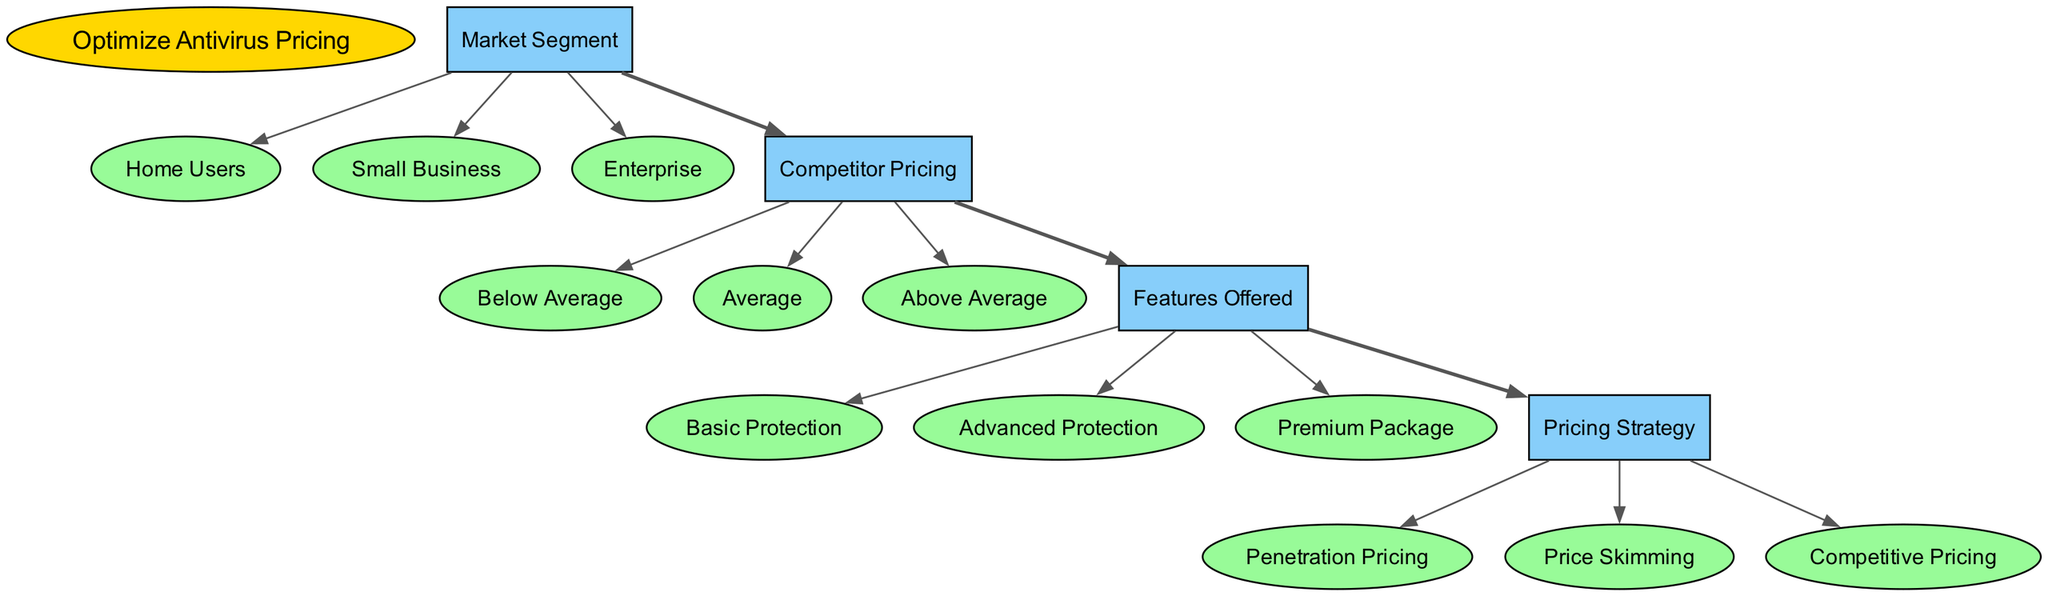What is the root node of the diagram? The root node is specified at the top of the diagram and is labeled "Optimize Antivirus Pricing."
Answer: Optimize Antivirus Pricing How many market segments are identified in the diagram? There are three distinct market segments listed under the "Market Segment" node: Home Users, Small Business, and Enterprise.
Answer: 3 What pricing strategy is associated with Advanced Protection? The "Features Offered" node leads to "Pricing Strategy," which includes all strategies regardless of the feature, but for Advanced Protection, the specific strategy could vary; it is not distinctly specified in the diagram. Since the diagram flows from "Features Offered" to "Pricing Strategy," the answer that applies generally is any of the pricing strategies could apply based on additional context.
Answer: Penetration Pricing, Price Skimming, Competitive Pricing Which node directly follows Competitor Pricing in the hierarchy? Competitor Pricing is followed by the "Features Offered" node, as shown by the defined edges indicating the flow from one to the other.
Answer: Features Offered What is the connection between Market Segment and Features Offered? The diagram specifies that there is an edge connecting "Market Segment" to "Competitor Pricing," and another edge from "Competitor Pricing" to "Features Offered," thus connecting the two indirectly through Competitor Pricing.
Answer: Indirectly through Competitor Pricing What is the number of edges in the diagram? The diagram shows three edges connecting the nodes, as detailed in the edges section. Each connection signifies a relationship between the nodes as outlined in the data.
Answer: 3 Which child node belongs to the "Features Offered"? Under "Features Offered," three child nodes are identified: Basic Protection, Advanced Protection, and Premium Package. Any of these would be a correct answer to the question.
Answer: Basic Protection What type of nodes are used for the "Market Segment"? The children of the "Market Segment" node are displayed in a specific shape, which is defined in the diagram, indicating they are considered as distinct entities (as reflected in a child-line hierarchy), generally represented as ellipse-shaped nodes.
Answer: Ellipse What are the options for the 'Pricing Strategy' in the diagram? The diagram specifies three distinct pricing strategies available at that node: Penetration Pricing, Price Skimming, and Competitive Pricing.
Answer: Penetration Pricing, Price Skimming, Competitive Pricing 